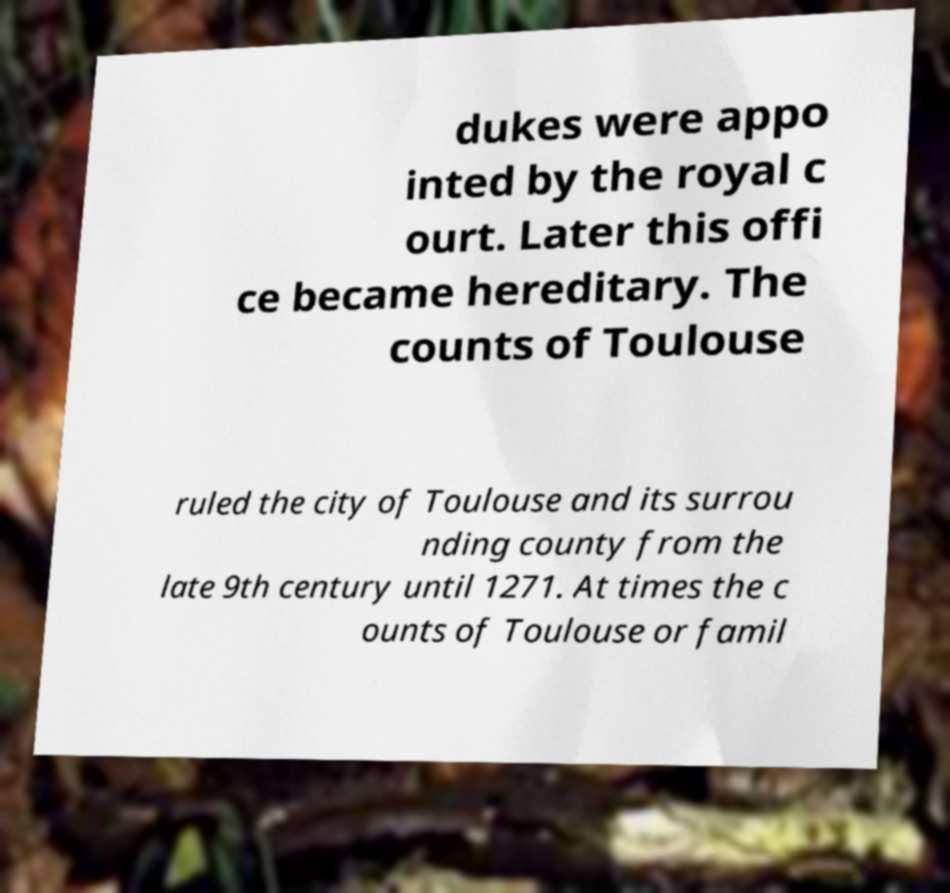There's text embedded in this image that I need extracted. Can you transcribe it verbatim? dukes were appo inted by the royal c ourt. Later this offi ce became hereditary. The counts of Toulouse ruled the city of Toulouse and its surrou nding county from the late 9th century until 1271. At times the c ounts of Toulouse or famil 